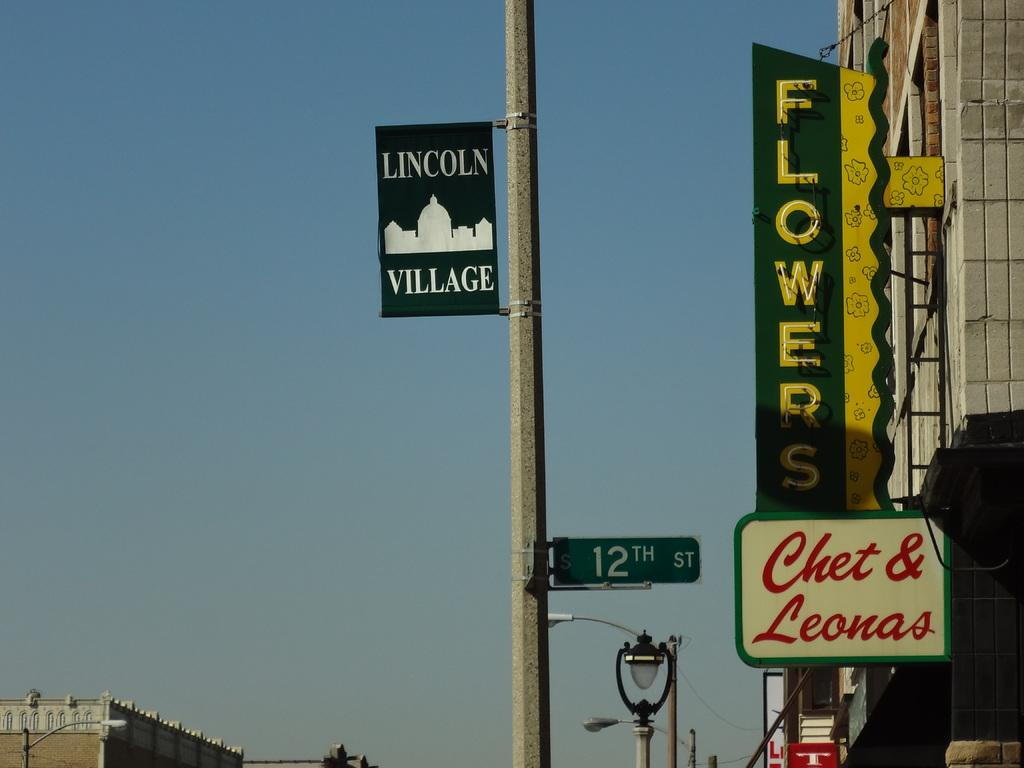<image>
Provide a brief description of the given image. A street sign reading Lincoln village in white on blue. 